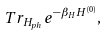Convert formula to latex. <formula><loc_0><loc_0><loc_500><loc_500>T r _ { H _ { p h } } e ^ { - \beta _ { H } H ^ { ( 0 ) } } ,</formula> 